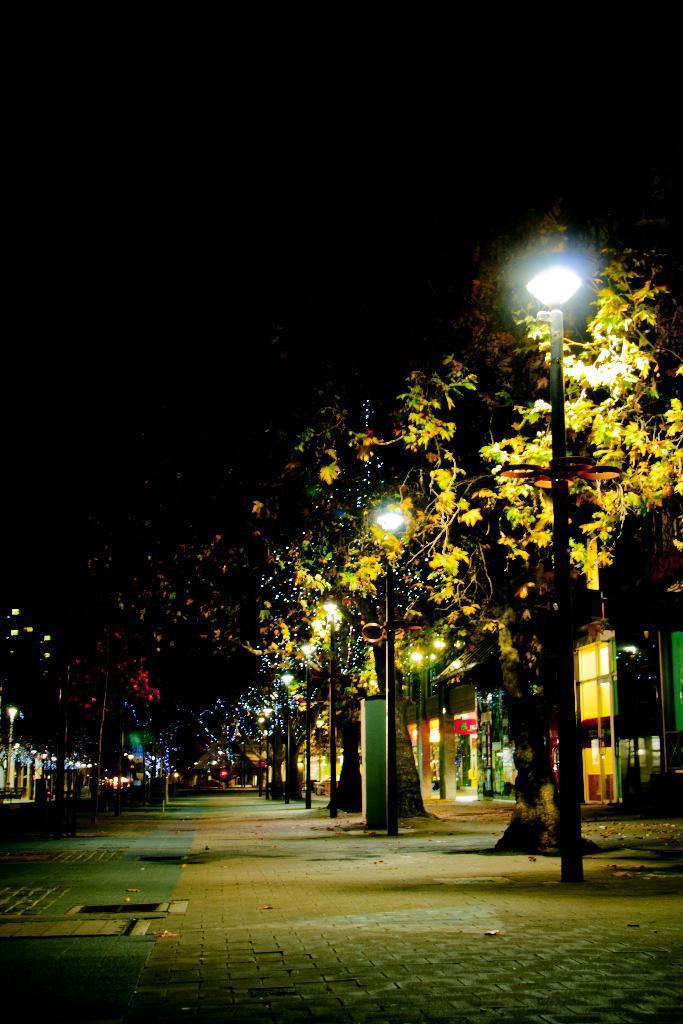How would you summarize this image in a sentence or two? In this image there are trees and we can see poles. There are lights. In the background there are buildings and sky. 